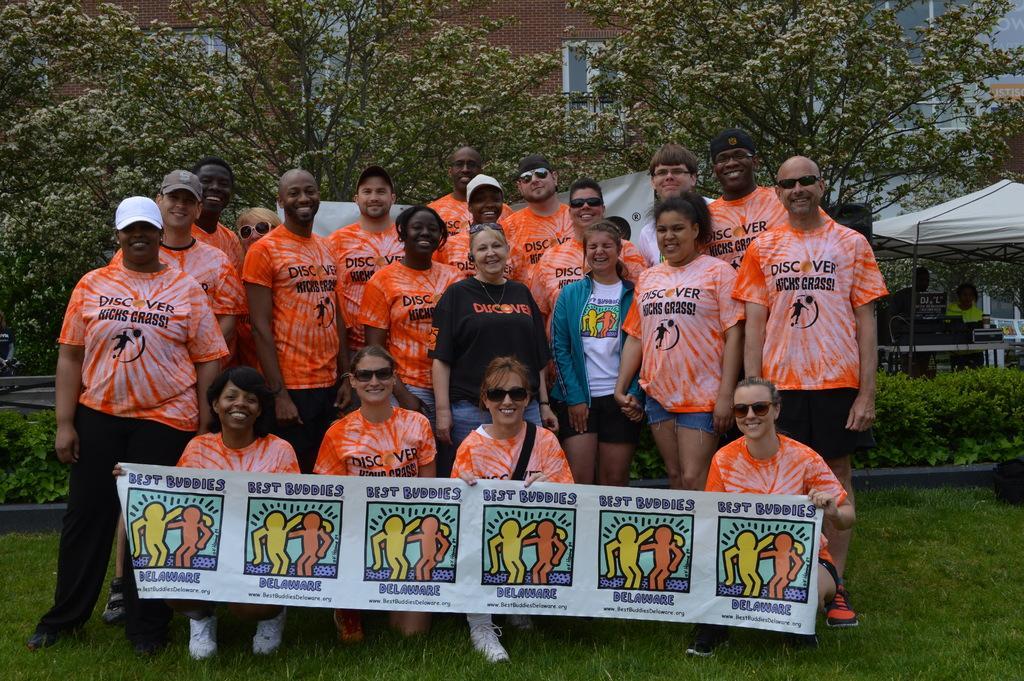In one or two sentences, can you explain what this image depicts? In the background we can see trees. Here we can see people holding a banner. We can see group of people standing and all are smiling. Here we can see plants and grass. At the right corner of the image we can see people. This is a tent. 